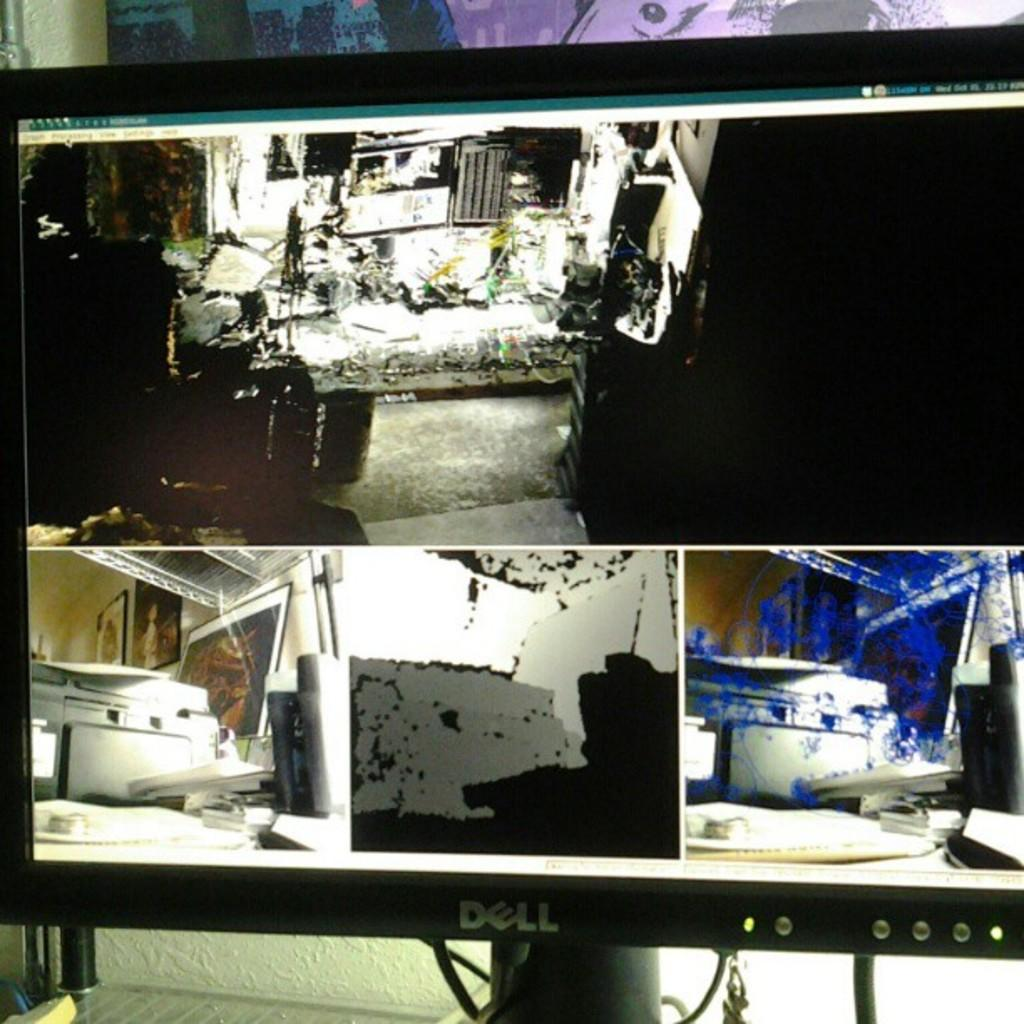<image>
Provide a brief description of the given image. A Dell computer shows a screen full of mechanical photos. 